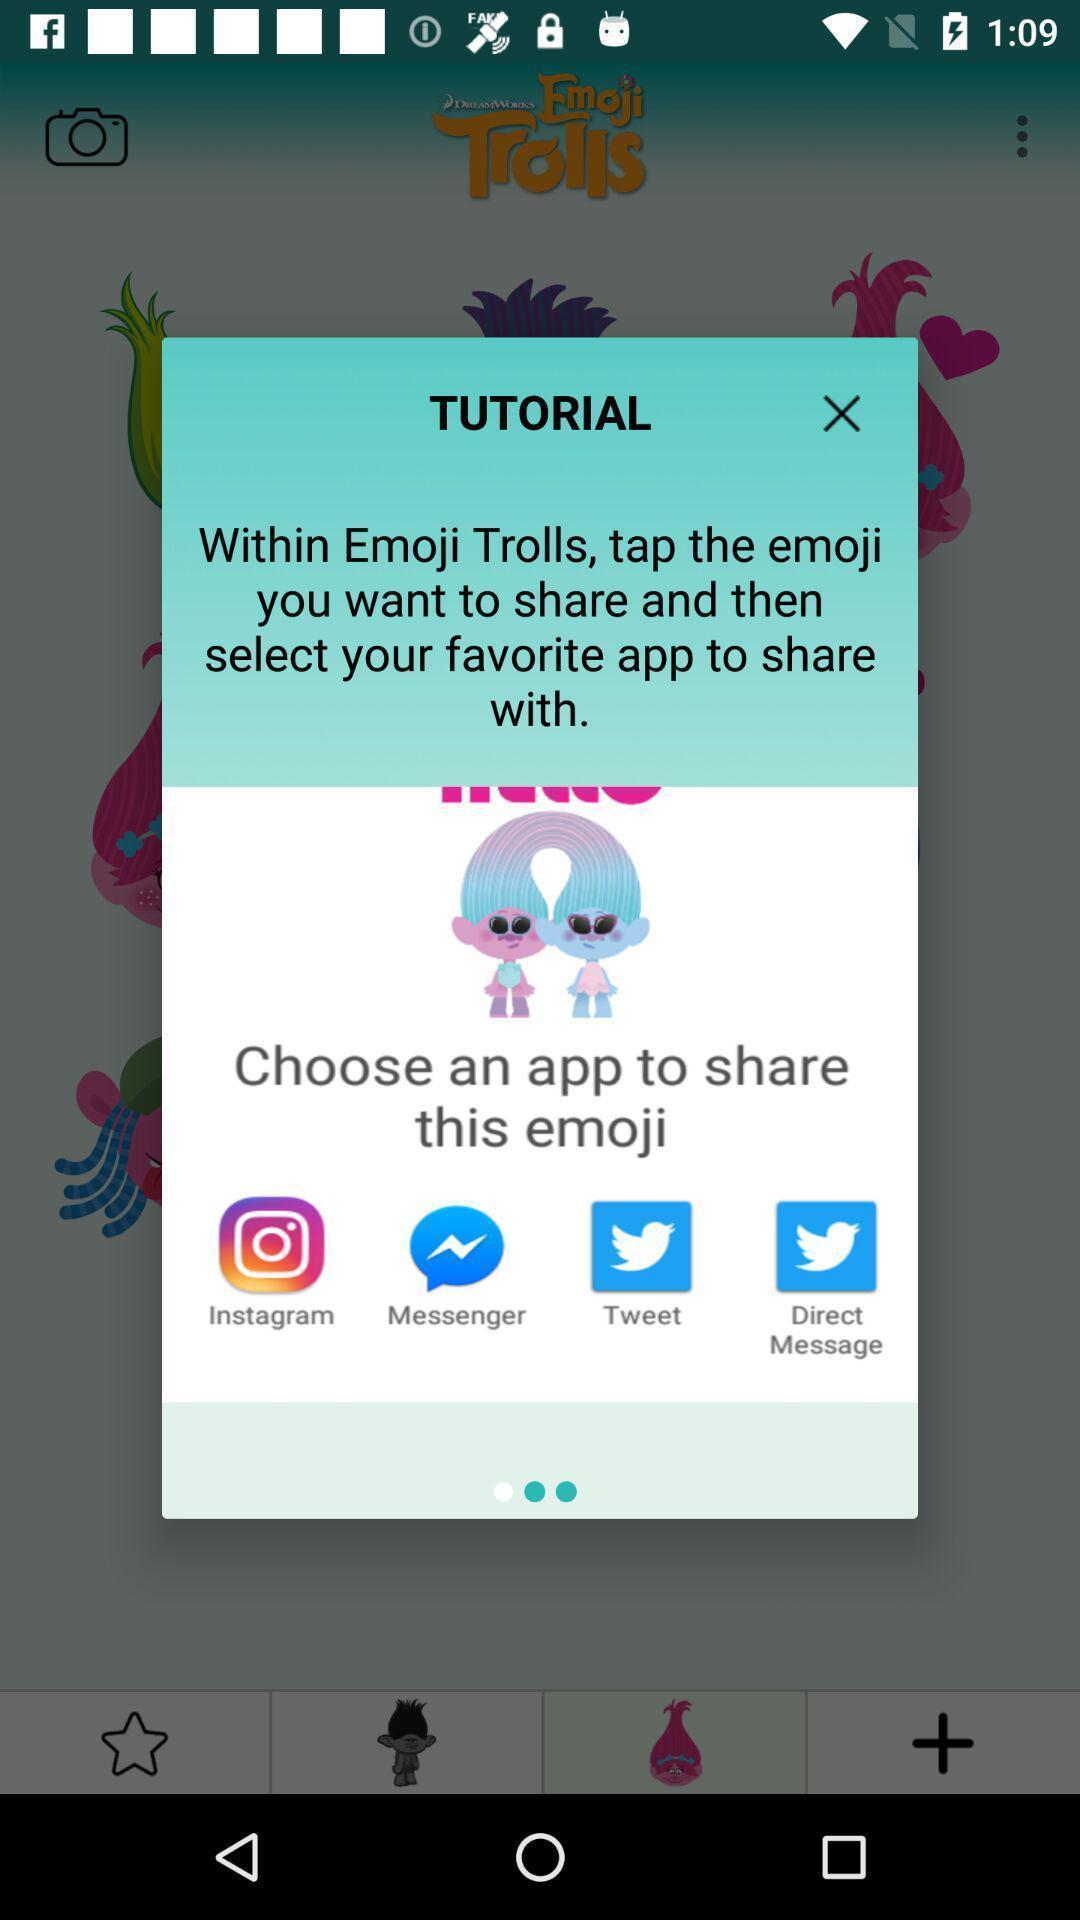Describe the visual elements of this screenshot. Popup showing tutorial. 